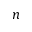<formula> <loc_0><loc_0><loc_500><loc_500>n</formula> 